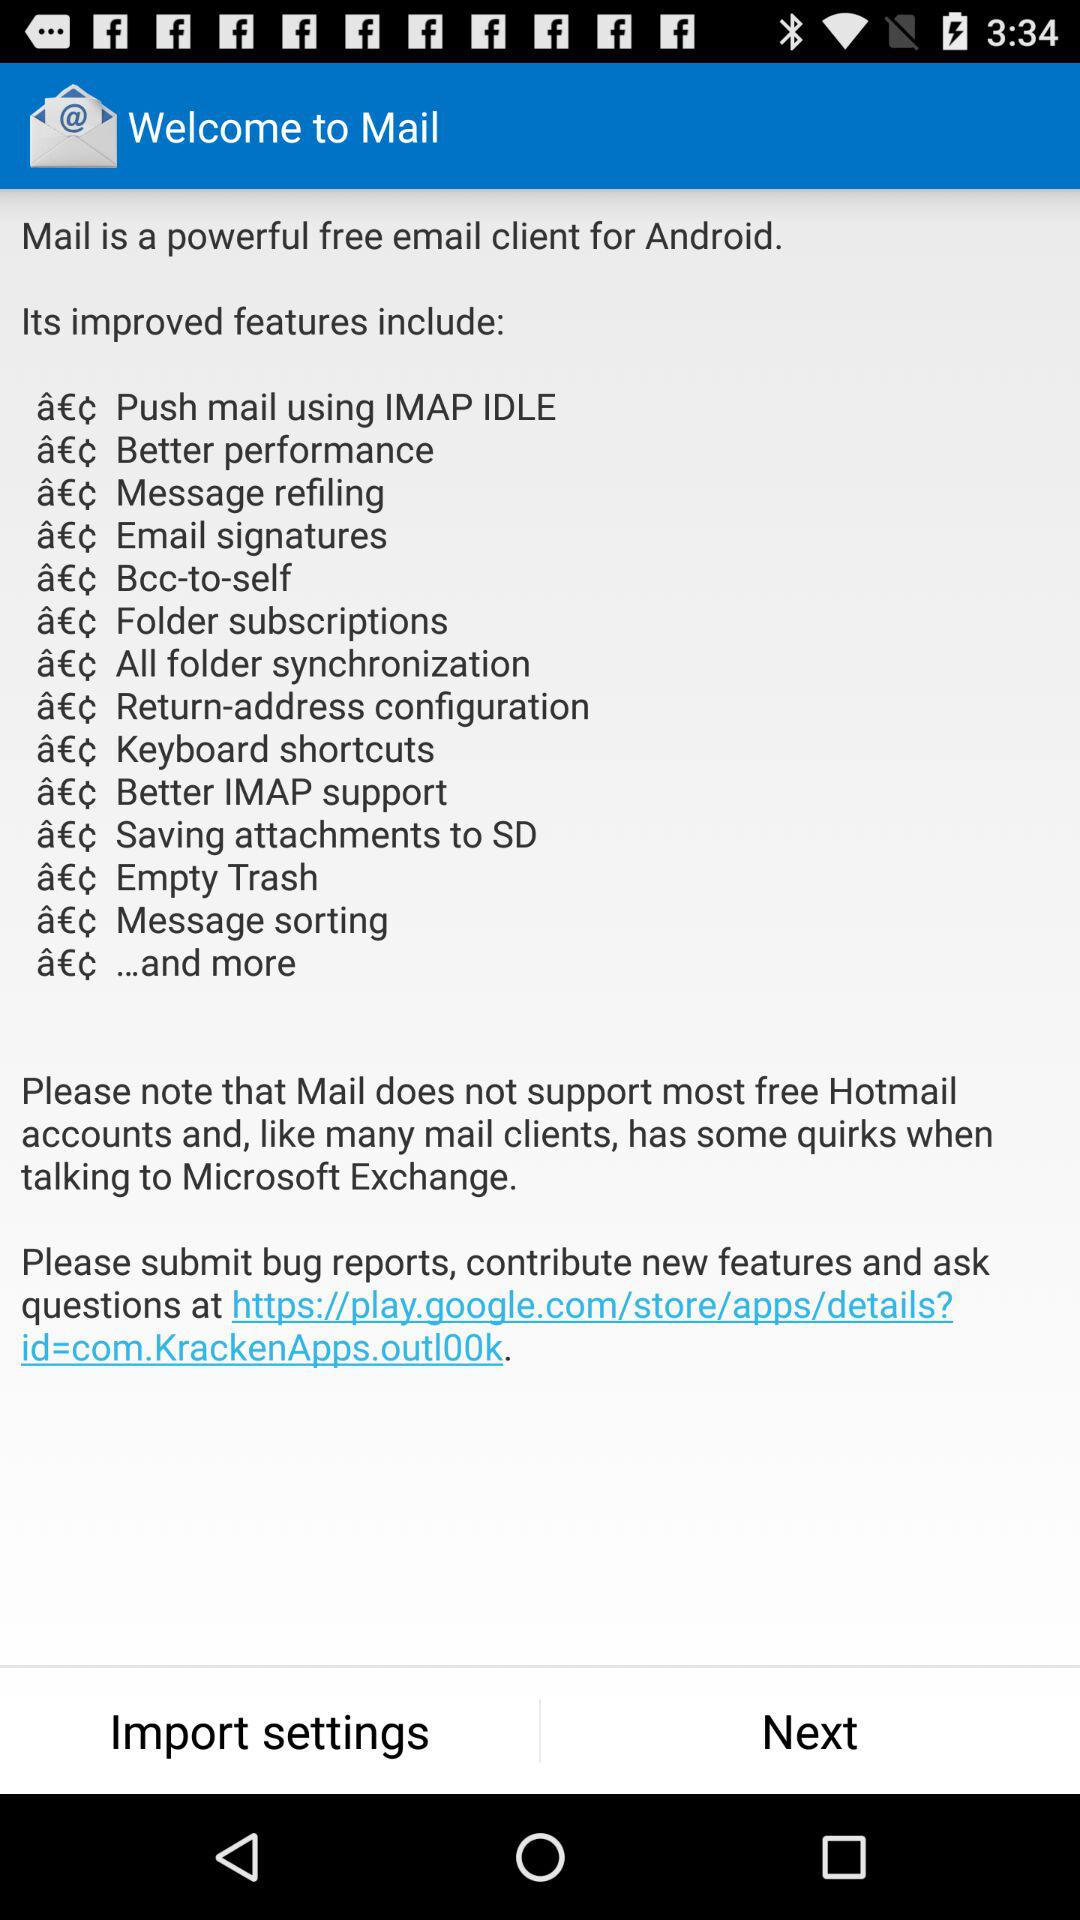What does the mail not support? Mail does not support most free Hotmail accounts and, like many mail clients, has some quirks when talking to Microsoft Exchange. 